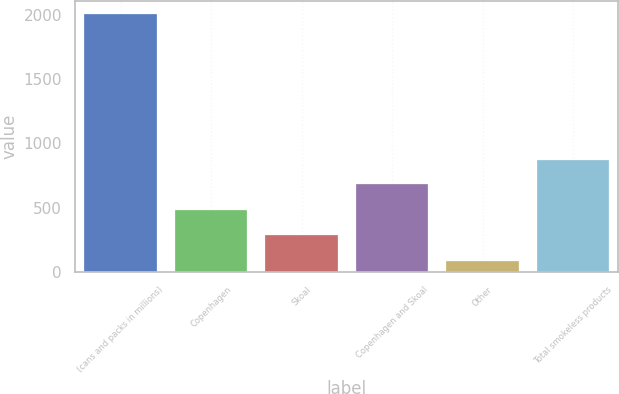<chart> <loc_0><loc_0><loc_500><loc_500><bar_chart><fcel>(cans and packs in millions)<fcel>Copenhagen<fcel>Skoal<fcel>Copenhagen and Skoal<fcel>Other<fcel>Total smokeless products<nl><fcel>2012<fcel>481.36<fcel>288.4<fcel>680.9<fcel>82.4<fcel>873.86<nl></chart> 